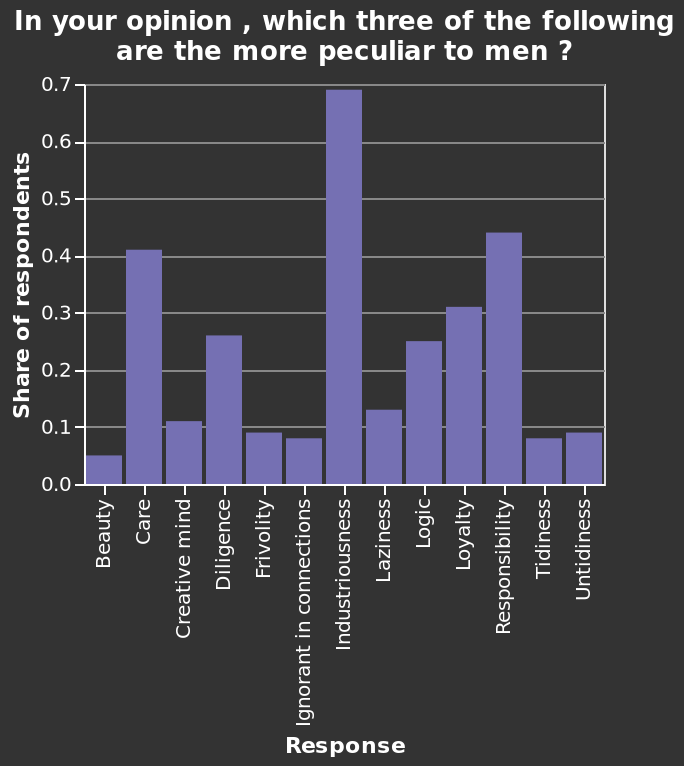<image>
What is the second most peculiar trait that men seem to have according to the respondents?  The second most peculiar trait that men seem to have according to the respondents is tidiness. What is the highest value on the y-axis of the bar diagram? The highest value on the y-axis is 0.7. What does the x-axis in the bar diagram represent?  The x-axis represents a categorical scale starting with Beauty and ending with Untidiness. Describe the following image in detail In your opinion , which three of the following are the more peculiar to men ? is a bar diagram. A categorical scale starting with Beauty and ending with Untidiness can be found along the x-axis, marked Response. There is a scale from 0.0 to 0.7 along the y-axis, marked Share of respondents. 